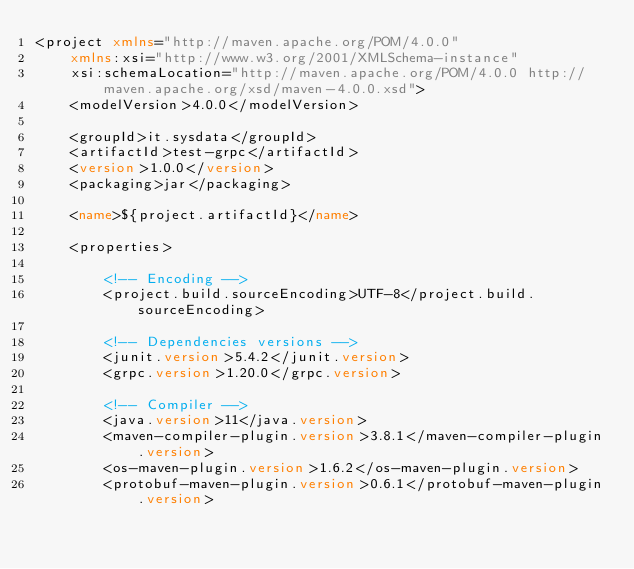Convert code to text. <code><loc_0><loc_0><loc_500><loc_500><_XML_><project xmlns="http://maven.apache.org/POM/4.0.0"
	xmlns:xsi="http://www.w3.org/2001/XMLSchema-instance"
	xsi:schemaLocation="http://maven.apache.org/POM/4.0.0 http://maven.apache.org/xsd/maven-4.0.0.xsd">
	<modelVersion>4.0.0</modelVersion>

	<groupId>it.sysdata</groupId>
	<artifactId>test-grpc</artifactId>
	<version>1.0.0</version>
	<packaging>jar</packaging>

	<name>${project.artifactId}</name>

	<properties>

		<!-- Encoding -->
		<project.build.sourceEncoding>UTF-8</project.build.sourceEncoding>

		<!-- Dependencies versions -->
		<junit.version>5.4.2</junit.version>
		<grpc.version>1.20.0</grpc.version>

		<!-- Compiler -->
		<java.version>11</java.version>
		<maven-compiler-plugin.version>3.8.1</maven-compiler-plugin.version>
		<os-maven-plugin.version>1.6.2</os-maven-plugin.version>
		<protobuf-maven-plugin.version>0.6.1</protobuf-maven-plugin.version></code> 